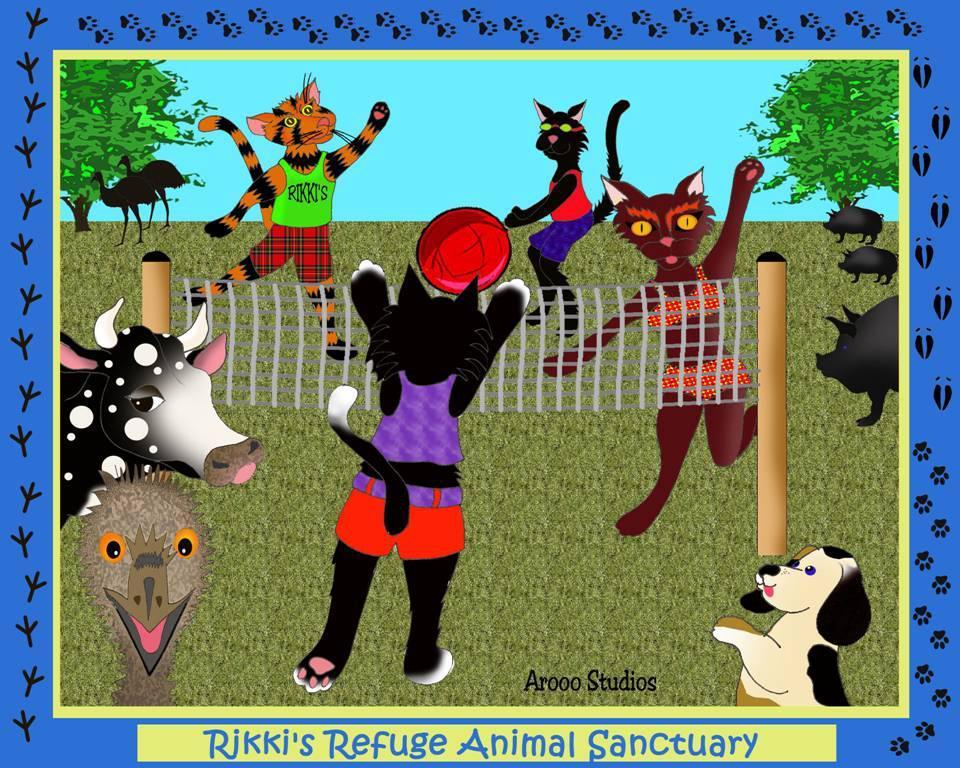In one or two sentences, can you explain what this image depicts? This image consists of a poster with a few images of animals, a net, trees, birds and there is a text on it. 